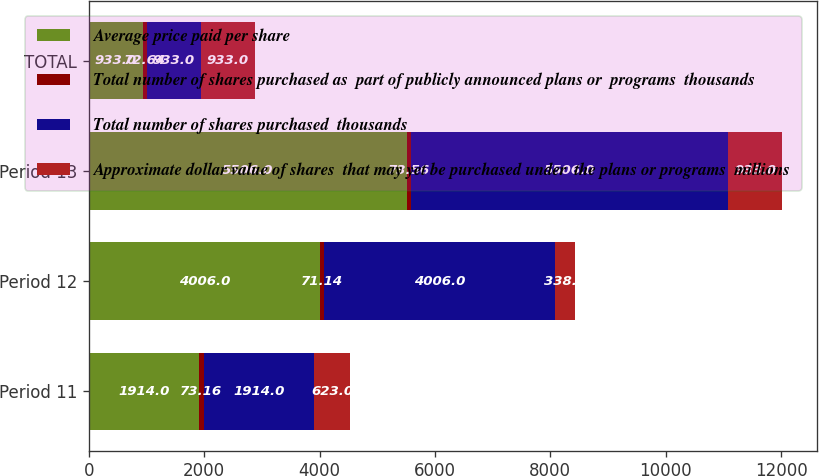Convert chart to OTSL. <chart><loc_0><loc_0><loc_500><loc_500><stacked_bar_chart><ecel><fcel>Period 11<fcel>Period 12<fcel>Period 13<fcel>TOTAL<nl><fcel>Average price paid per share<fcel>1914<fcel>4006<fcel>5506<fcel>933<nl><fcel>Total number of shares purchased as  part of publicly announced plans or  programs  thousands<fcel>73.16<fcel>71.14<fcel>73.56<fcel>72.64<nl><fcel>Total number of shares purchased  thousands<fcel>1914<fcel>4006<fcel>5506<fcel>933<nl><fcel>Approximate dollar value of shares  that may yet be purchased under  the plans or programs  millions<fcel>623<fcel>338<fcel>933<fcel>933<nl></chart> 